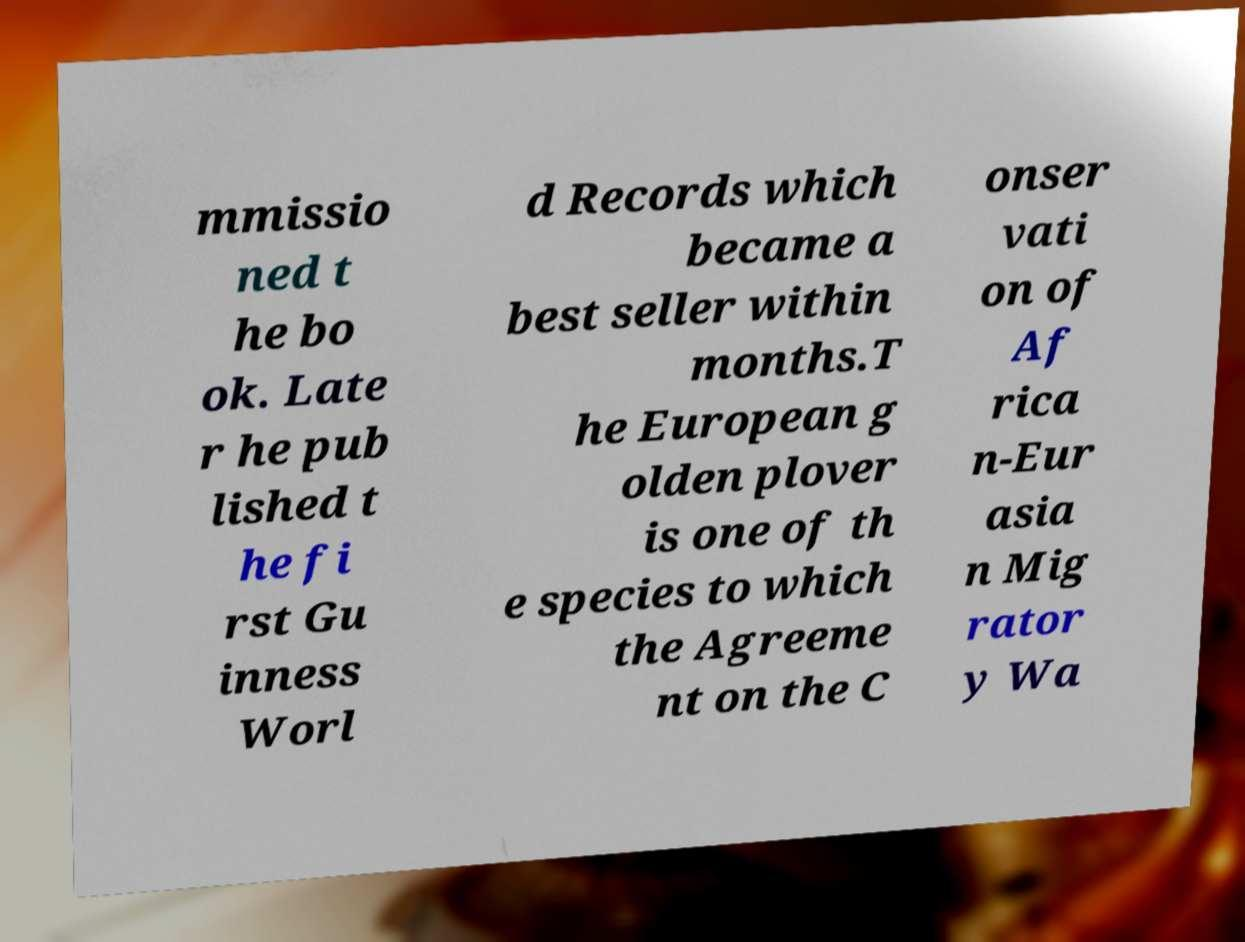For documentation purposes, I need the text within this image transcribed. Could you provide that? mmissio ned t he bo ok. Late r he pub lished t he fi rst Gu inness Worl d Records which became a best seller within months.T he European g olden plover is one of th e species to which the Agreeme nt on the C onser vati on of Af rica n-Eur asia n Mig rator y Wa 